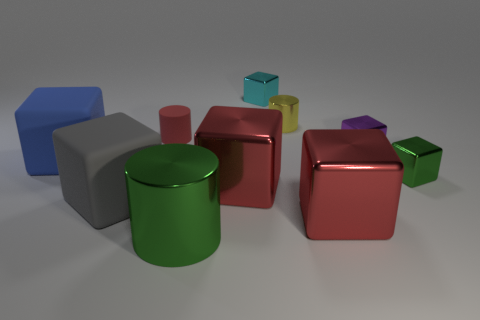Subtract 4 cubes. How many cubes are left? 3 Subtract all large red blocks. How many blocks are left? 5 Subtract all blue cubes. How many cubes are left? 6 Subtract all green cubes. Subtract all brown spheres. How many cubes are left? 6 Subtract all cylinders. How many objects are left? 7 Add 3 blue matte blocks. How many blue matte blocks exist? 4 Subtract 0 red balls. How many objects are left? 10 Subtract all red rubber cylinders. Subtract all cyan blocks. How many objects are left? 8 Add 1 big green metallic objects. How many big green metallic objects are left? 2 